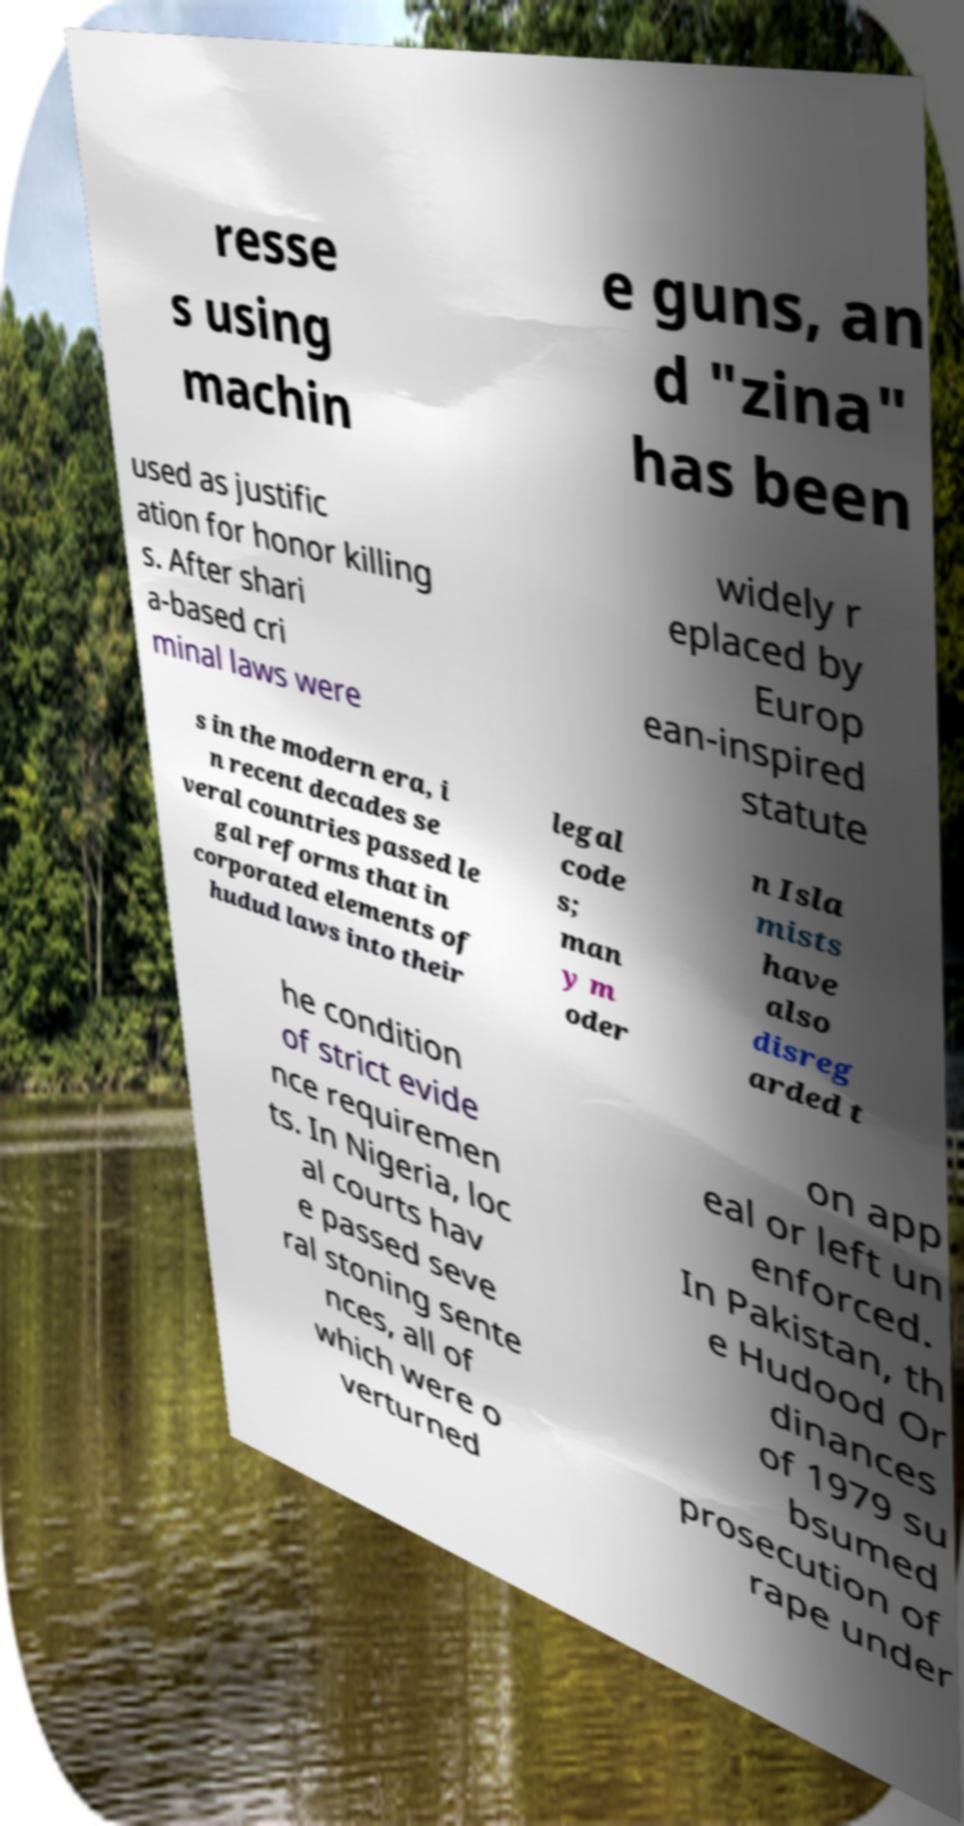Please identify and transcribe the text found in this image. resse s using machin e guns, an d "zina" has been used as justific ation for honor killing s. After shari a-based cri minal laws were widely r eplaced by Europ ean-inspired statute s in the modern era, i n recent decades se veral countries passed le gal reforms that in corporated elements of hudud laws into their legal code s; man y m oder n Isla mists have also disreg arded t he condition of strict evide nce requiremen ts. In Nigeria, loc al courts hav e passed seve ral stoning sente nces, all of which were o verturned on app eal or left un enforced. In Pakistan, th e Hudood Or dinances of 1979 su bsumed prosecution of rape under 